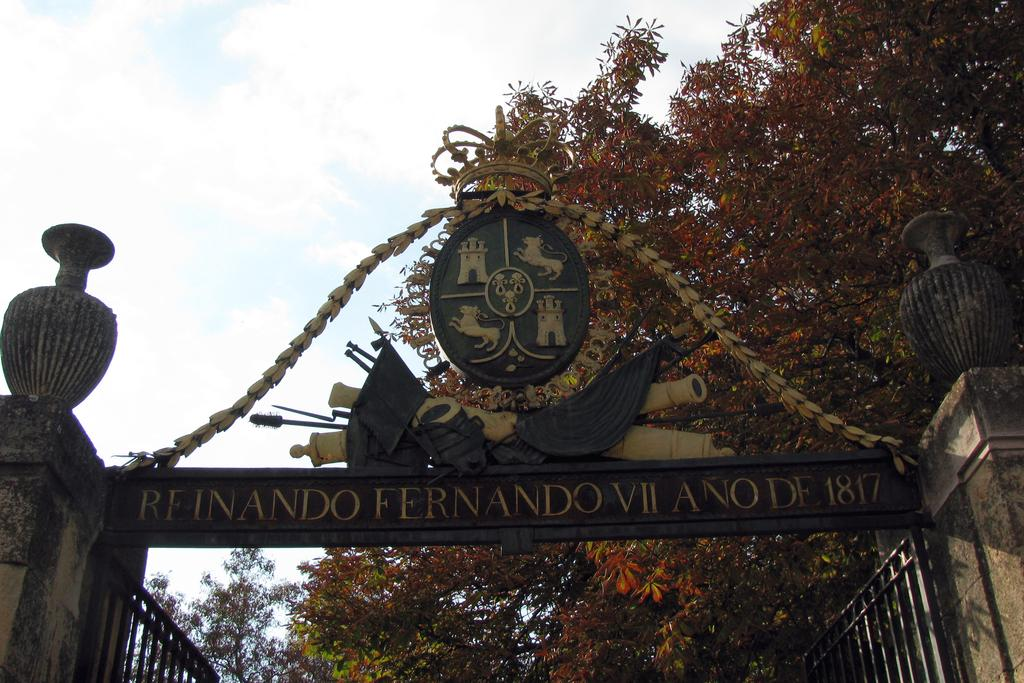<image>
Create a compact narrative representing the image presented. An ornate sign above a gate has the year 1817 on it. 